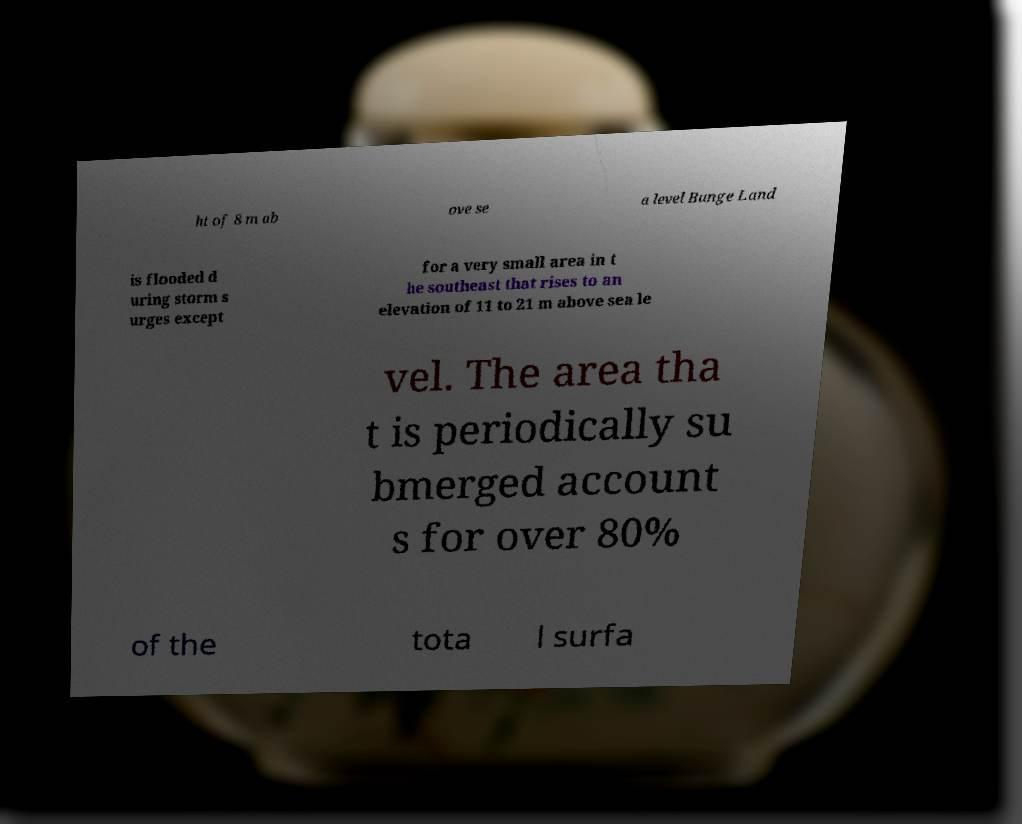Could you extract and type out the text from this image? ht of 8 m ab ove se a level Bunge Land is flooded d uring storm s urges except for a very small area in t he southeast that rises to an elevation of 11 to 21 m above sea le vel. The area tha t is periodically su bmerged account s for over 80% of the tota l surfa 